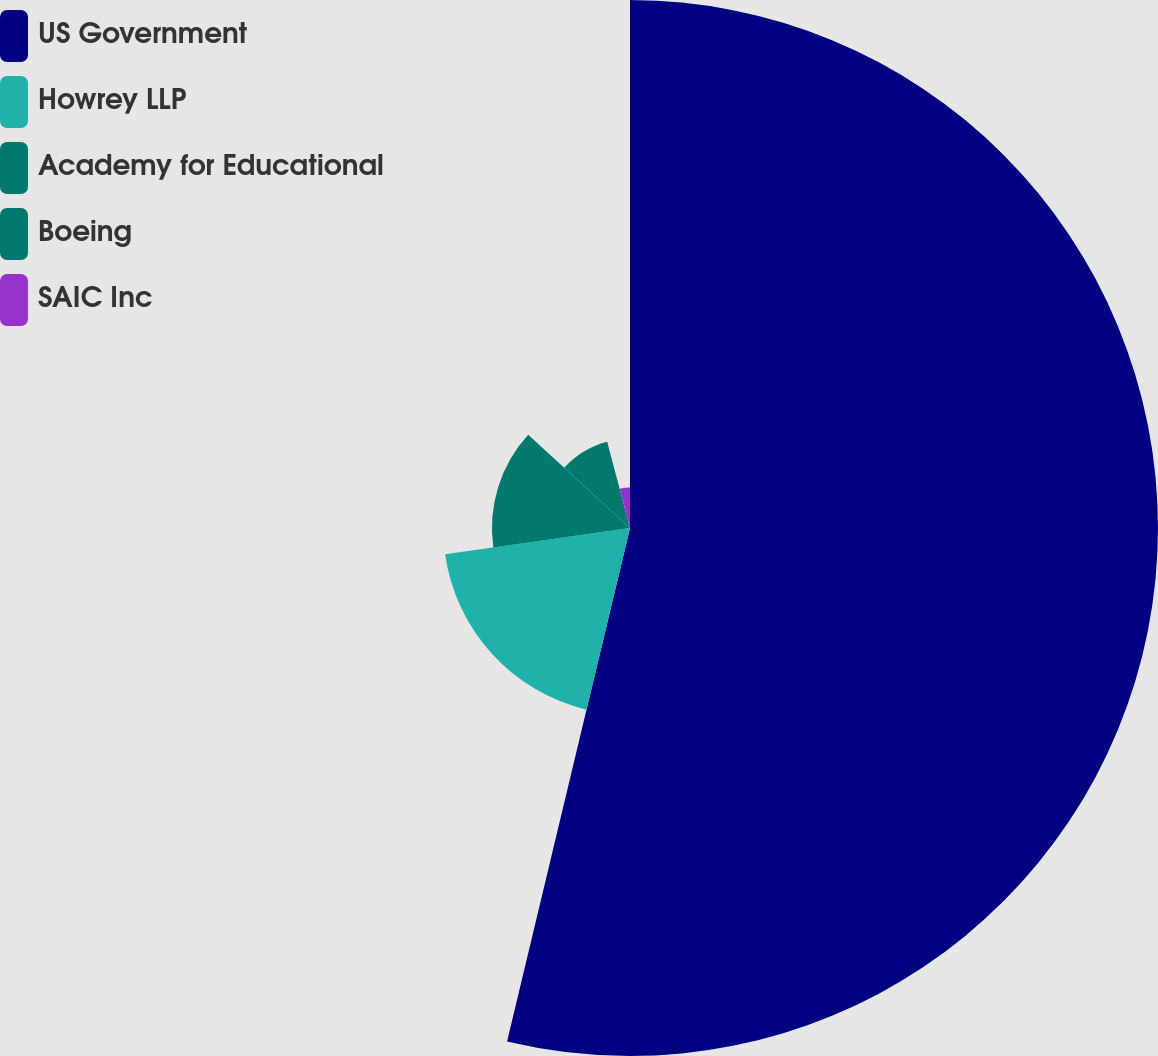Convert chart to OTSL. <chart><loc_0><loc_0><loc_500><loc_500><pie_chart><fcel>US Government<fcel>Howrey LLP<fcel>Academy for Educational<fcel>Boeing<fcel>SAIC Inc<nl><fcel>53.74%<fcel>19.01%<fcel>14.05%<fcel>9.08%<fcel>4.12%<nl></chart> 